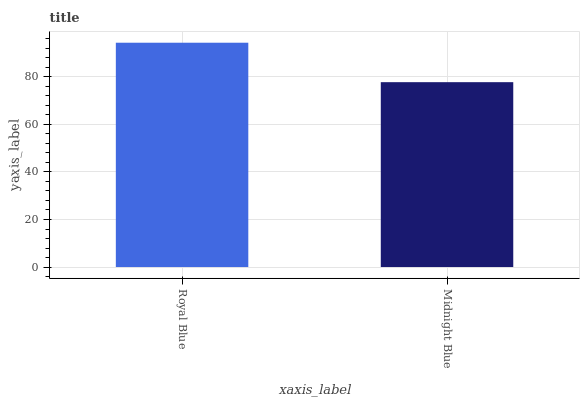Is Midnight Blue the minimum?
Answer yes or no. Yes. Is Royal Blue the maximum?
Answer yes or no. Yes. Is Midnight Blue the maximum?
Answer yes or no. No. Is Royal Blue greater than Midnight Blue?
Answer yes or no. Yes. Is Midnight Blue less than Royal Blue?
Answer yes or no. Yes. Is Midnight Blue greater than Royal Blue?
Answer yes or no. No. Is Royal Blue less than Midnight Blue?
Answer yes or no. No. Is Royal Blue the high median?
Answer yes or no. Yes. Is Midnight Blue the low median?
Answer yes or no. Yes. Is Midnight Blue the high median?
Answer yes or no. No. Is Royal Blue the low median?
Answer yes or no. No. 